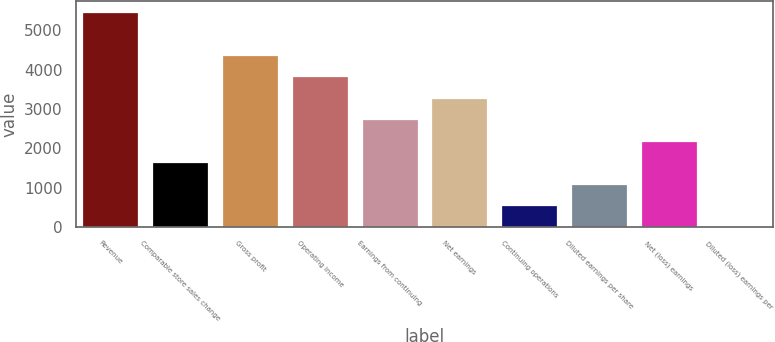Convert chart. <chart><loc_0><loc_0><loc_500><loc_500><bar_chart><fcel>Revenue<fcel>Comparable store sales change<fcel>Gross profit<fcel>Operating income<fcel>Earnings from continuing<fcel>Net earnings<fcel>Continuing operations<fcel>Diluted earnings per share<fcel>Net (loss) earnings<fcel>Diluted (loss) earnings per<nl><fcel>5479<fcel>1643.75<fcel>4383.2<fcel>3835.31<fcel>2739.53<fcel>3287.42<fcel>547.97<fcel>1095.86<fcel>2191.64<fcel>0.08<nl></chart> 